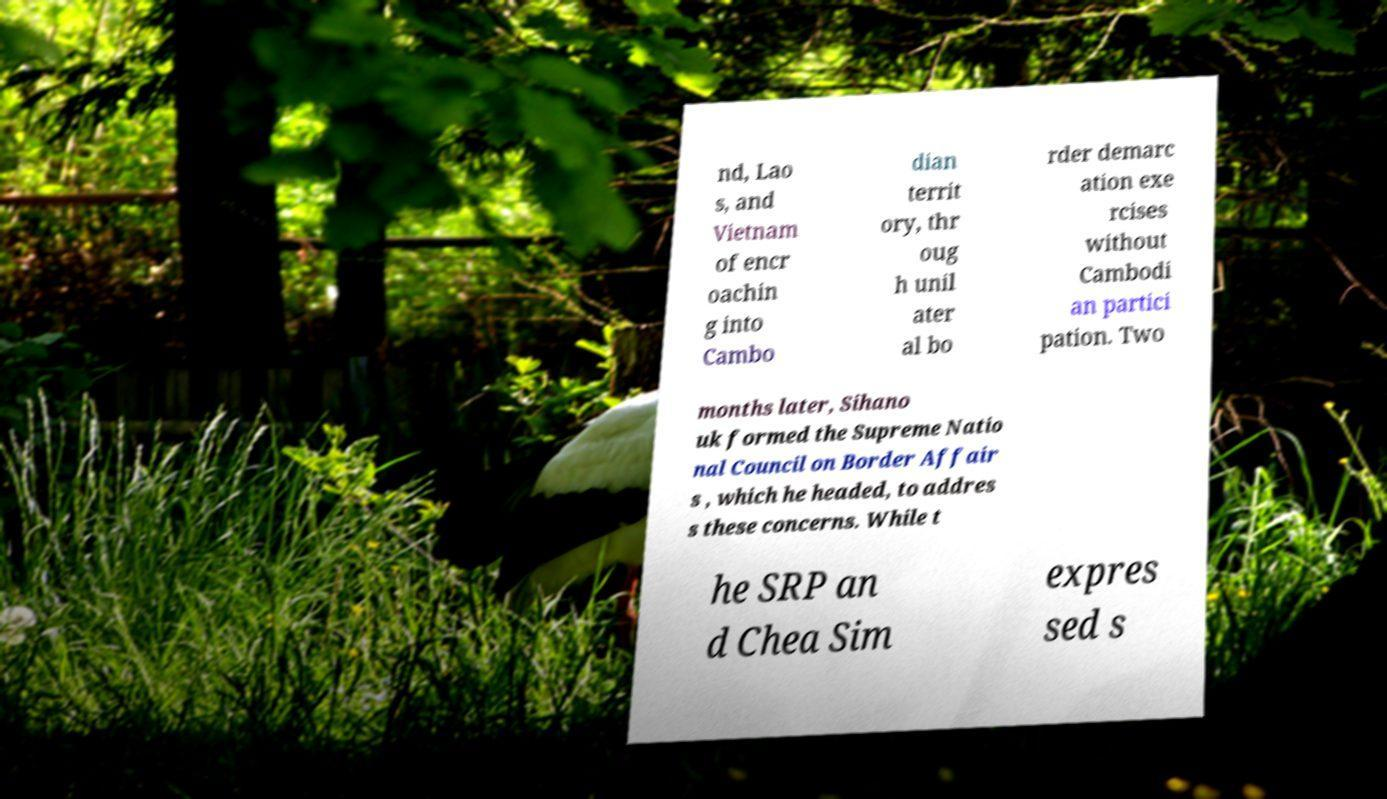Could you assist in decoding the text presented in this image and type it out clearly? nd, Lao s, and Vietnam of encr oachin g into Cambo dian territ ory, thr oug h unil ater al bo rder demarc ation exe rcises without Cambodi an partici pation. Two months later, Sihano uk formed the Supreme Natio nal Council on Border Affair s , which he headed, to addres s these concerns. While t he SRP an d Chea Sim expres sed s 